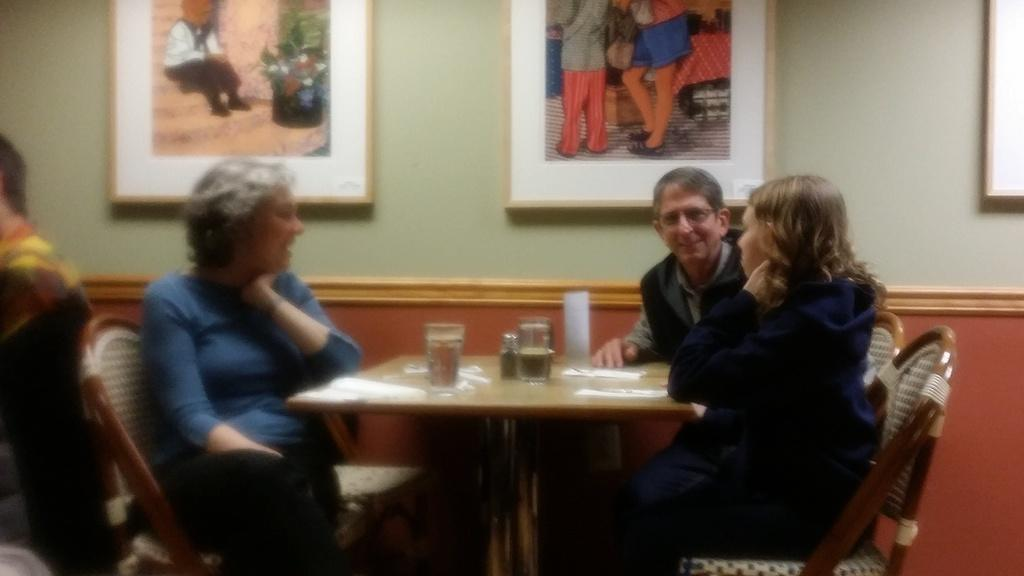What are the people in the image doing? The people in the image are sitting on chairs near a table. What objects can be seen on the table? There are glasses, papers, and tissues on the table. What is visible in the background of the image? There is a photo frame and a wall in the background. What type of ornament is hanging from the ceiling in the image? There is no ornament hanging from the ceiling in the image. Is there a patch on the wall in the image? The image does not show any patches on the wall. 